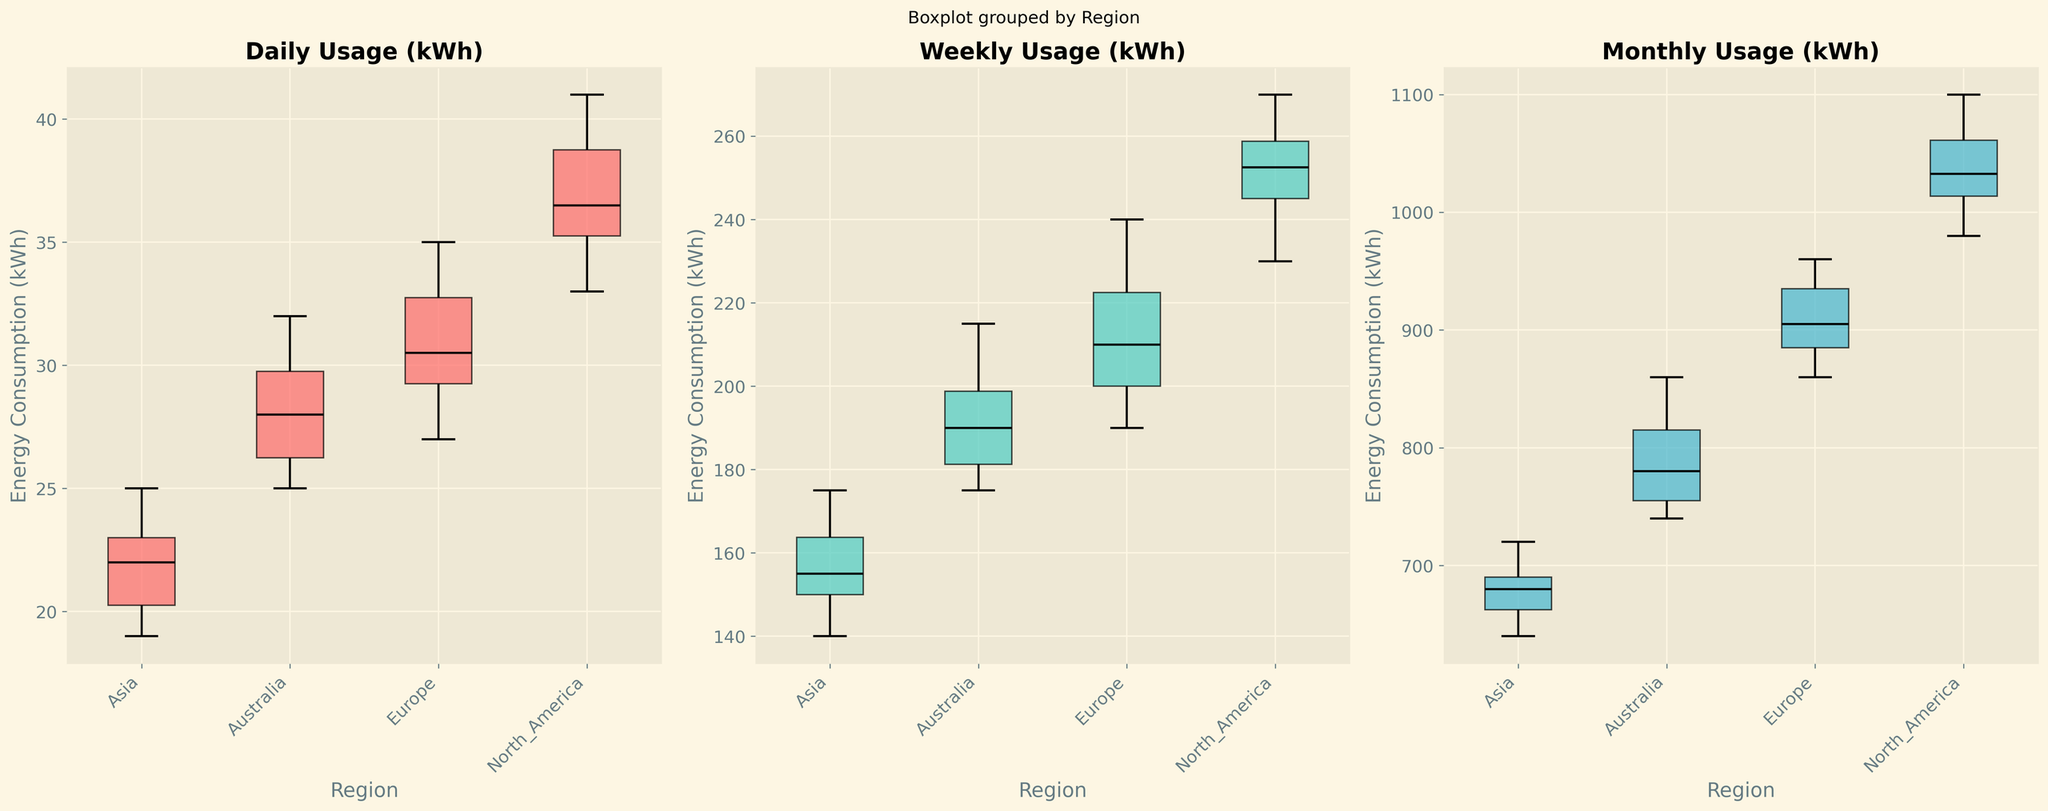Which region has the highest median daily energy consumption? By examining the box plots for daily energy consumption, the median value is indicated by the black line inside each box. The region where this line is the highest shows the highest median daily energy consumption.
Answer: North America How does the range of weekly energy consumption in Europe compare to that in Asia? The range can be determined by the distance between the top and bottom whiskers of the box plots for weekly energy consumption. Compare this distance between Europe and Asia.
Answer: Europe's range is larger than Asia's Which region shows the greatest variability in monthly energy consumption? Variability can be assessed by the height of the box and the length of the whiskers in the monthly energy consumption box plot. The region with the tallest whiskers and box indicates the greatest variability.
Answer: North America What's the interquartile range (IQR) of daily energy consumption in Australia? The IQR is the range between the first quartile (bottom of the box) and the third quartile (top of the box). Measure this range in the daily energy consumption box plot for Australia.
Answer: Approximately 4 kWh Can you identify any outliers in the weekly energy consumption for any region? Outliers are usually shown as individual points outside the whiskers of the box plot. Look at the weekly energy consumption box plots to identify any outliers.
Answer: No clear outliers visible Compare the average monthly energy consumption between Europe and Asia. The average can be visually estimated from the box plot as the midpoint of the box (median) combined with the spread. Compare these midpoints and spreads for monthly consumption between Europe and Asia.
Answer: Europe's average is higher than Asia's Which region has the lowest median weekly energy consumption? The median value is represented by the black line inside each box. Determine which region has the lowest median value in the weekly usage plot.
Answer: Asia Does any region have similar median daily energy consumption to another region? Compare the median lines for daily energy consumption across regions to see if any regions have similar values.
Answer: North America and Europe are similar What can you infer about the consistency of energy consumption in Australia on a monthly basis? Consistency can be inferred from the height of the box and whiskers. A shorter box and whiskers indicate more consistent data.
Answer: Relatively consistent, with moderate variability Among all the regions, which one shows the smallest interquartile range (IQR) for weekly consumption? The IQR is indicated by the height of the box. Identify the region with the smallest box height for weekly energy consumption.
Answer: Asia 